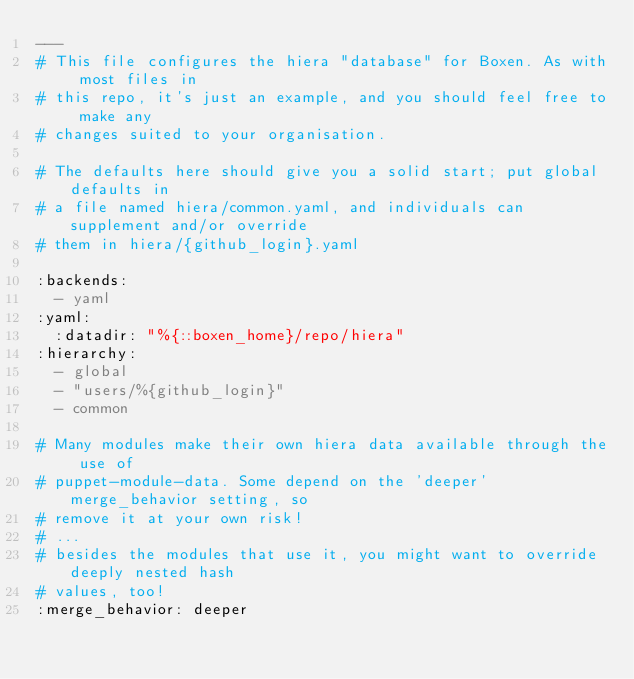<code> <loc_0><loc_0><loc_500><loc_500><_YAML_>---
# This file configures the hiera "database" for Boxen. As with most files in
# this repo, it's just an example, and you should feel free to make any
# changes suited to your organisation.

# The defaults here should give you a solid start; put global defaults in
# a file named hiera/common.yaml, and individuals can supplement and/or override
# them in hiera/{github_login}.yaml

:backends:
  - yaml
:yaml:
  :datadir: "%{::boxen_home}/repo/hiera"
:hierarchy:
  - global
  - "users/%{github_login}"
  - common

# Many modules make their own hiera data available through the use of
# puppet-module-data. Some depend on the 'deeper' merge_behavior setting, so
# remove it at your own risk!
# ...
# besides the modules that use it, you might want to override deeply nested hash
# values, too!
:merge_behavior: deeper
</code> 